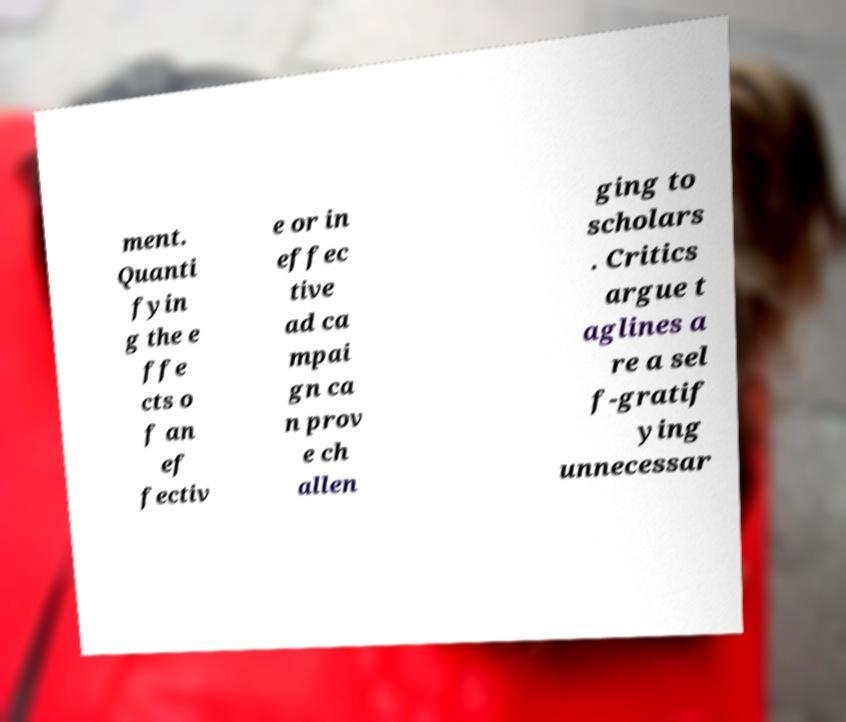For documentation purposes, I need the text within this image transcribed. Could you provide that? ment. Quanti fyin g the e ffe cts o f an ef fectiv e or in effec tive ad ca mpai gn ca n prov e ch allen ging to scholars . Critics argue t aglines a re a sel f-gratif ying unnecessar 